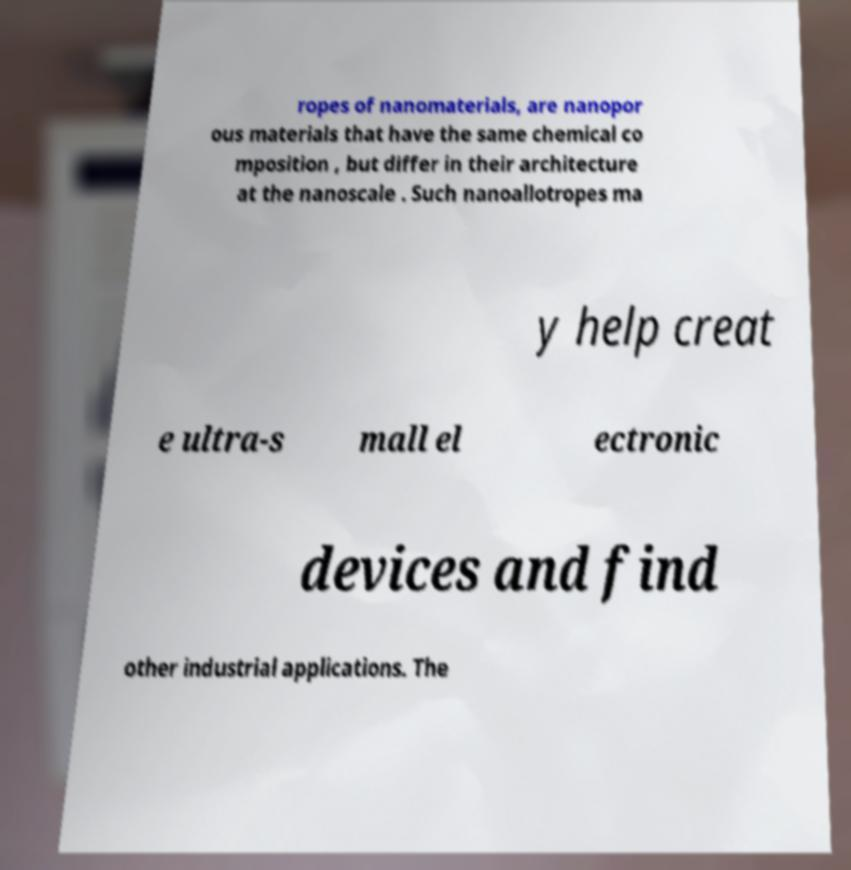Please read and relay the text visible in this image. What does it say? ropes of nanomaterials, are nanopor ous materials that have the same chemical co mposition , but differ in their architecture at the nanoscale . Such nanoallotropes ma y help creat e ultra-s mall el ectronic devices and find other industrial applications. The 